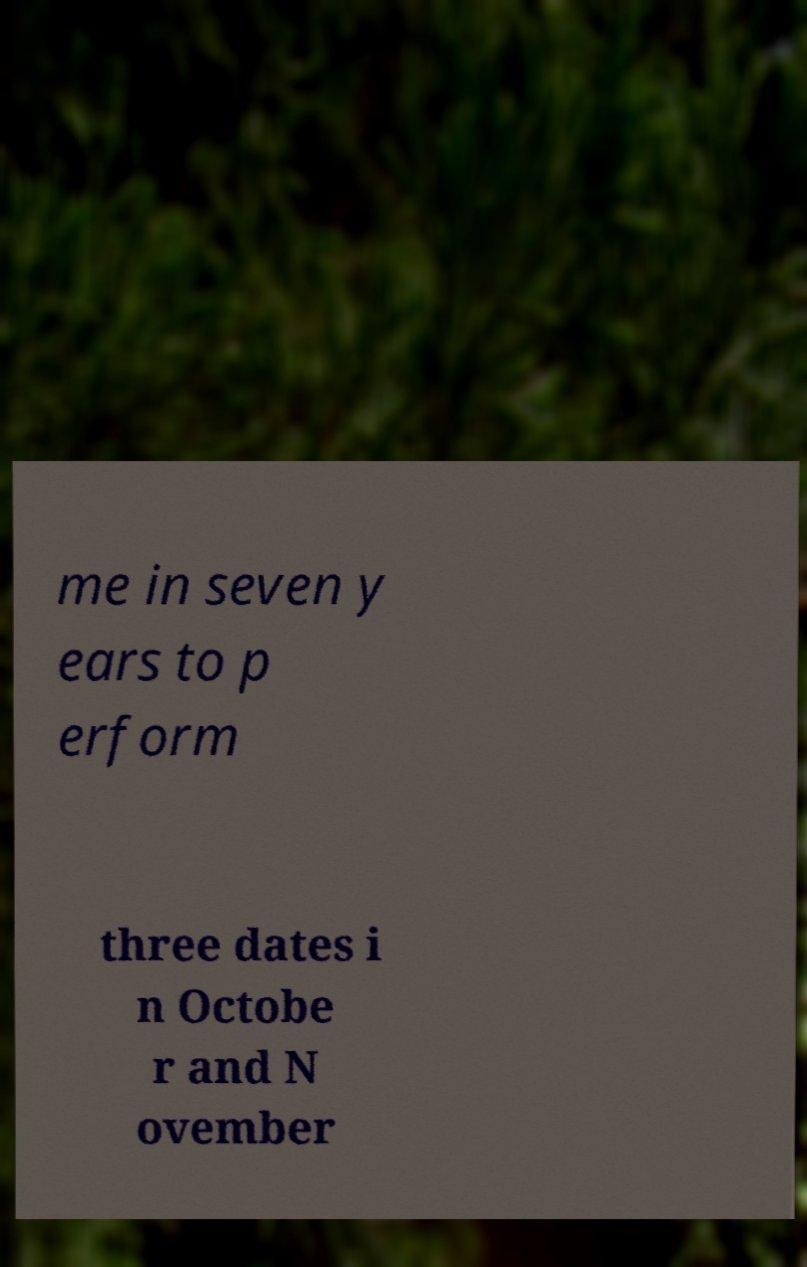Could you extract and type out the text from this image? me in seven y ears to p erform three dates i n Octobe r and N ovember 